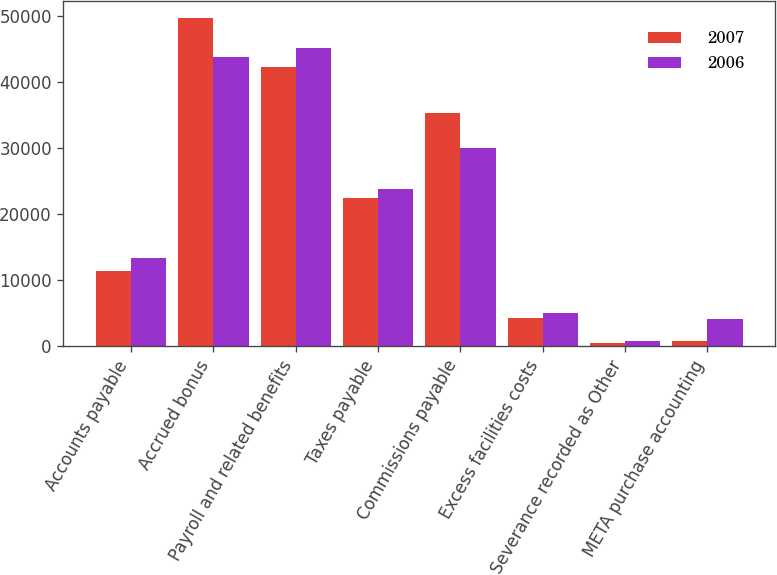<chart> <loc_0><loc_0><loc_500><loc_500><stacked_bar_chart><ecel><fcel>Accounts payable<fcel>Accrued bonus<fcel>Payroll and related benefits<fcel>Taxes payable<fcel>Commissions payable<fcel>Excess facilities costs<fcel>Severance recorded as Other<fcel>META purchase accounting<nl><fcel>2007<fcel>11264<fcel>49792<fcel>42297<fcel>22454<fcel>35347<fcel>4116<fcel>336<fcel>671<nl><fcel>2006<fcel>13333<fcel>43901<fcel>45143<fcel>23795<fcel>30080<fcel>4896<fcel>681<fcel>3969<nl></chart> 